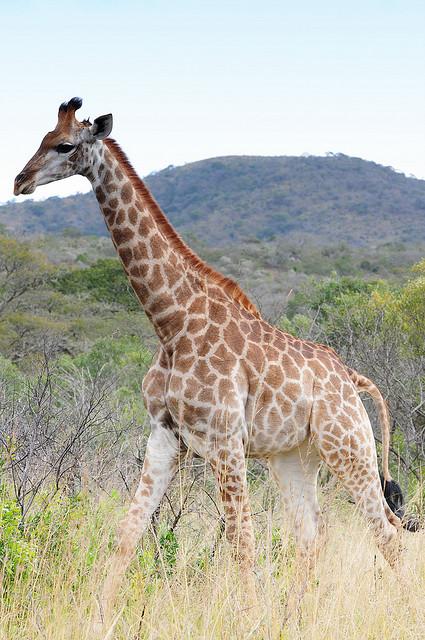What are the giraffes doing?
Quick response, please. Walking. Is the animal's mouth open?
Short answer required. No. Is it daytime?
Give a very brief answer. Yes. Is the giraffe moving?
Concise answer only. Yes. Is this animal in the wild?
Quick response, please. Yes. What kind of animal is this?
Short answer required. Giraffe. 